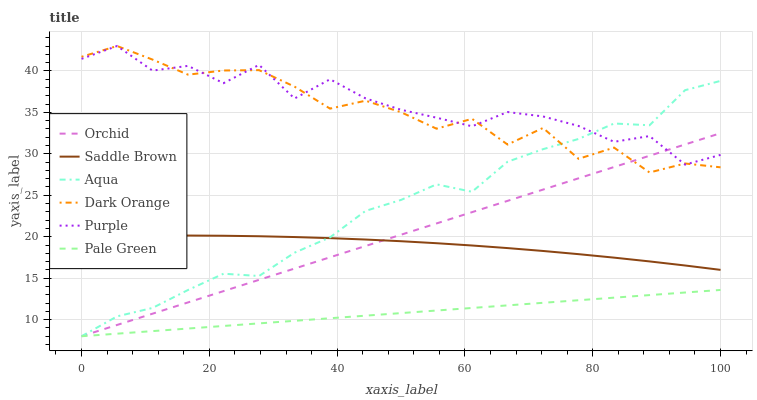Does Pale Green have the minimum area under the curve?
Answer yes or no. Yes. Does Purple have the maximum area under the curve?
Answer yes or no. Yes. Does Aqua have the minimum area under the curve?
Answer yes or no. No. Does Aqua have the maximum area under the curve?
Answer yes or no. No. Is Orchid the smoothest?
Answer yes or no. Yes. Is Purple the roughest?
Answer yes or no. Yes. Is Aqua the smoothest?
Answer yes or no. No. Is Aqua the roughest?
Answer yes or no. No. Does Purple have the lowest value?
Answer yes or no. No. Does Purple have the highest value?
Answer yes or no. Yes. Does Aqua have the highest value?
Answer yes or no. No. Is Saddle Brown less than Dark Orange?
Answer yes or no. Yes. Is Dark Orange greater than Pale Green?
Answer yes or no. Yes. Does Aqua intersect Saddle Brown?
Answer yes or no. Yes. Is Aqua less than Saddle Brown?
Answer yes or no. No. Is Aqua greater than Saddle Brown?
Answer yes or no. No. Does Saddle Brown intersect Dark Orange?
Answer yes or no. No. 